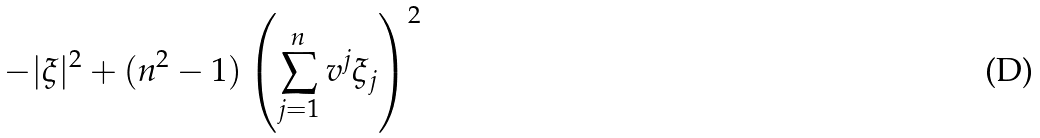Convert formula to latex. <formula><loc_0><loc_0><loc_500><loc_500>- | \xi | ^ { 2 } + ( n ^ { 2 } - 1 ) \left ( \sum _ { j = 1 } ^ { n } v ^ { j } \xi _ { j } \right ) ^ { 2 }</formula> 